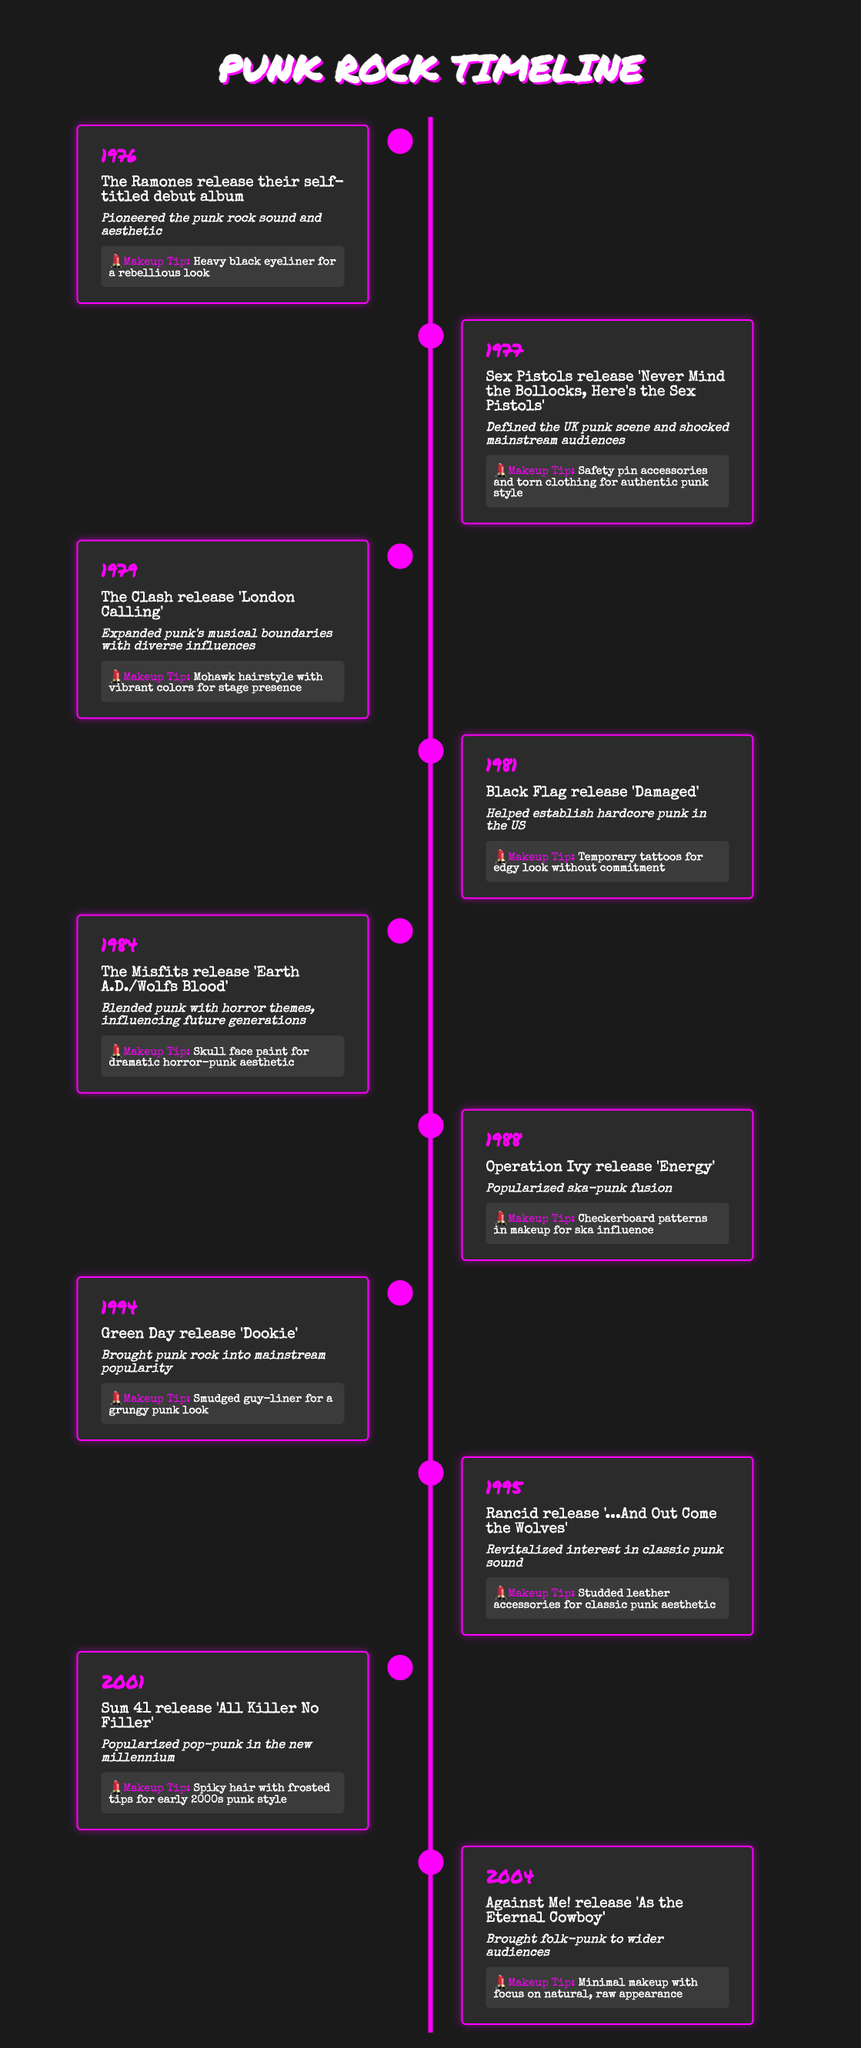What year did The Clash release 'London Calling'? The data shows that 'London Calling' was released in 1979, as indicated in the entry for that year.
Answer: 1979 How many albums are listed in the timeline? There are ten entries in the timeline, each corresponding to a different album release, so the total is 10.
Answer: 10 Which band released an album in 1984? The timeline specifies that The Misfits released 'Earth A.D./Wolfs Blood' in 1984.
Answer: The Misfits Was Green Day's release in 1994 significant for mainstream popularity? Yes, the timeline indicates that Green Day's album 'Dookie' brought punk rock into mainstream popularity, confirming its significance.
Answer: Yes What is the impact of Rancid’s album released in 1995? The impact stated in the timeline for Rancid’s album '...And Out Come the Wolves' is that it revitalized interest in classic punk sound.
Answer: Revitalized interest in classic punk sound What year is associated with the introduction of skull face paint? The entry for 1984 mentions that The Misfits' album led to the use of skull face paint for a dramatic horror-punk aesthetic.
Answer: 1984 Which band's release in 2001 popularized pop-punk? According to the timeline, Sum 41’s album 'All Killer No Filler' released in 2001 popularized pop-punk.
Answer: Sum 41 What makeup tip is recommended for the year 1994? The timeline specifies that the makeup tip for 1994 is "Smudged guy-liner for a grungy punk look," referring to Green Day’s release.
Answer: Smudged guy-liner How does the impact of Black Flag's album relate to hardcore punk? The timeline indicates that Black Flag's 'Damaged' in 1981 helped establish hardcore punk in the US, highlighting its influence on that subgenre of punk.
Answer: Established hardcore punk in the US What year saw a release that combined horror themes with punk? The 1984 release by The Misfits is noted for blending punk with horror themes, as mentioned in its impact statement.
Answer: 1984 